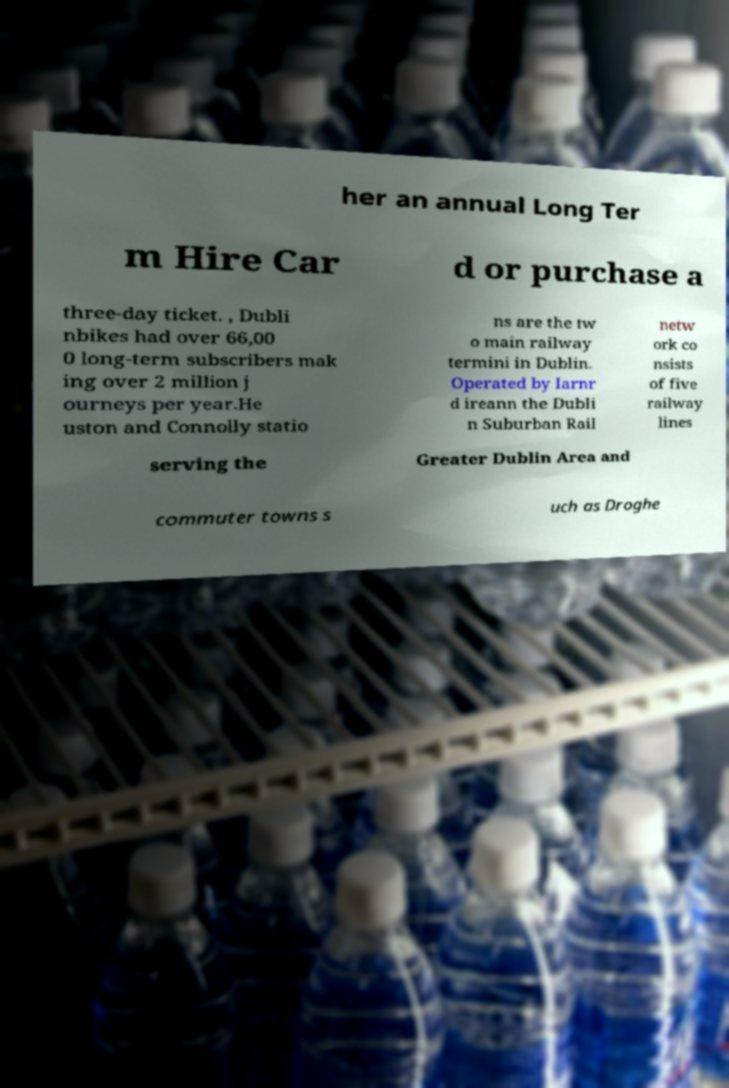Can you accurately transcribe the text from the provided image for me? her an annual Long Ter m Hire Car d or purchase a three-day ticket. , Dubli nbikes had over 66,00 0 long-term subscribers mak ing over 2 million j ourneys per year.He uston and Connolly statio ns are the tw o main railway termini in Dublin. Operated by Iarnr d ireann the Dubli n Suburban Rail netw ork co nsists of five railway lines serving the Greater Dublin Area and commuter towns s uch as Droghe 